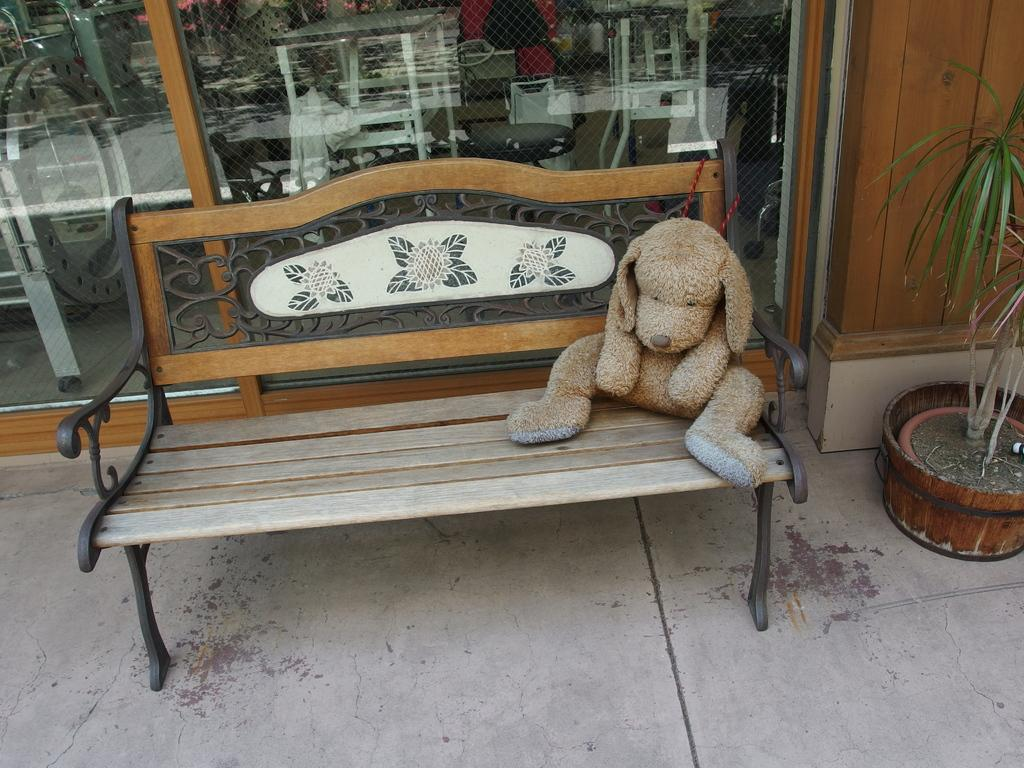What type of seating is present in the image? There is a bench in the image. What is on the bench? There is a toy on the bench. What else can be seen in the image besides the bench and toy? There is a plant visible in the image. How many birds are in the flock that is sitting on the toy in the image? There is no flock of birds present in the image; it only features a bench, a toy, and a plant. 